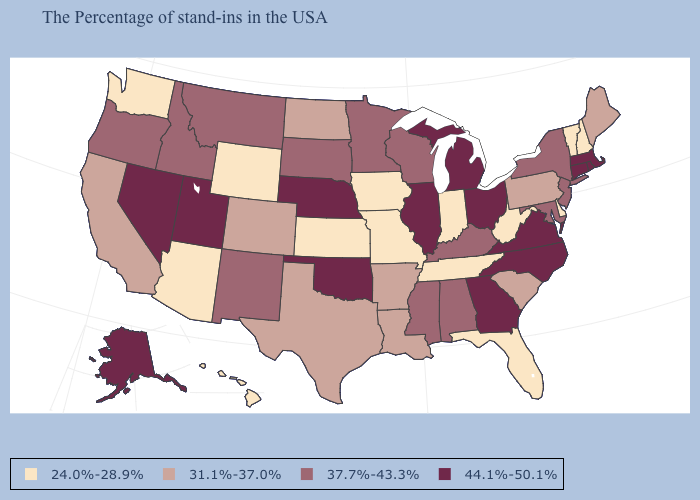How many symbols are there in the legend?
Be succinct. 4. What is the value of Louisiana?
Short answer required. 31.1%-37.0%. Is the legend a continuous bar?
Short answer required. No. Does the map have missing data?
Concise answer only. No. Among the states that border Michigan , which have the lowest value?
Keep it brief. Indiana. Among the states that border North Carolina , does Georgia have the highest value?
Concise answer only. Yes. What is the highest value in the MidWest ?
Write a very short answer. 44.1%-50.1%. What is the value of Arizona?
Keep it brief. 24.0%-28.9%. Among the states that border Missouri , which have the lowest value?
Concise answer only. Tennessee, Iowa, Kansas. Does Michigan have the highest value in the USA?
Write a very short answer. Yes. What is the value of Florida?
Be succinct. 24.0%-28.9%. Name the states that have a value in the range 31.1%-37.0%?
Write a very short answer. Maine, Pennsylvania, South Carolina, Louisiana, Arkansas, Texas, North Dakota, Colorado, California. Does Kansas have a lower value than Rhode Island?
Short answer required. Yes. Does Tennessee have the lowest value in the South?
Answer briefly. Yes. Name the states that have a value in the range 31.1%-37.0%?
Give a very brief answer. Maine, Pennsylvania, South Carolina, Louisiana, Arkansas, Texas, North Dakota, Colorado, California. 